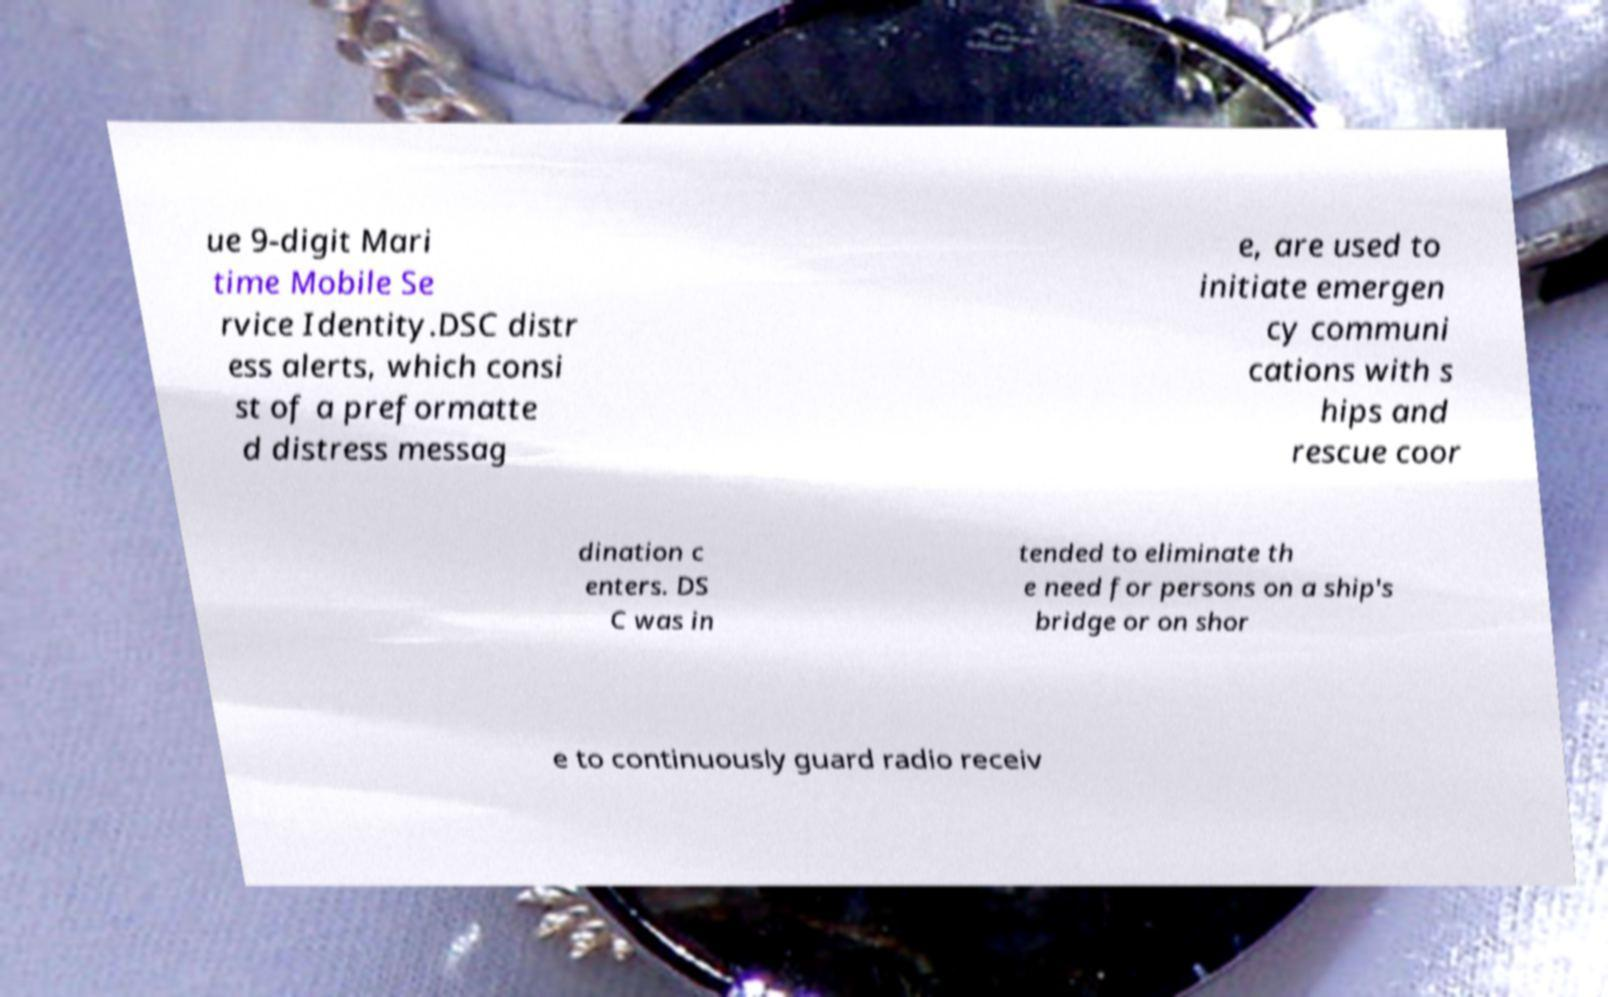Can you accurately transcribe the text from the provided image for me? ue 9-digit Mari time Mobile Se rvice Identity.DSC distr ess alerts, which consi st of a preformatte d distress messag e, are used to initiate emergen cy communi cations with s hips and rescue coor dination c enters. DS C was in tended to eliminate th e need for persons on a ship's bridge or on shor e to continuously guard radio receiv 